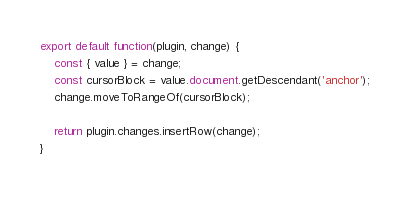Convert code to text. <code><loc_0><loc_0><loc_500><loc_500><_JavaScript_>export default function(plugin, change) {
    const { value } = change;
    const cursorBlock = value.document.getDescendant('anchor');
    change.moveToRangeOf(cursorBlock);

    return plugin.changes.insertRow(change);
}
</code> 